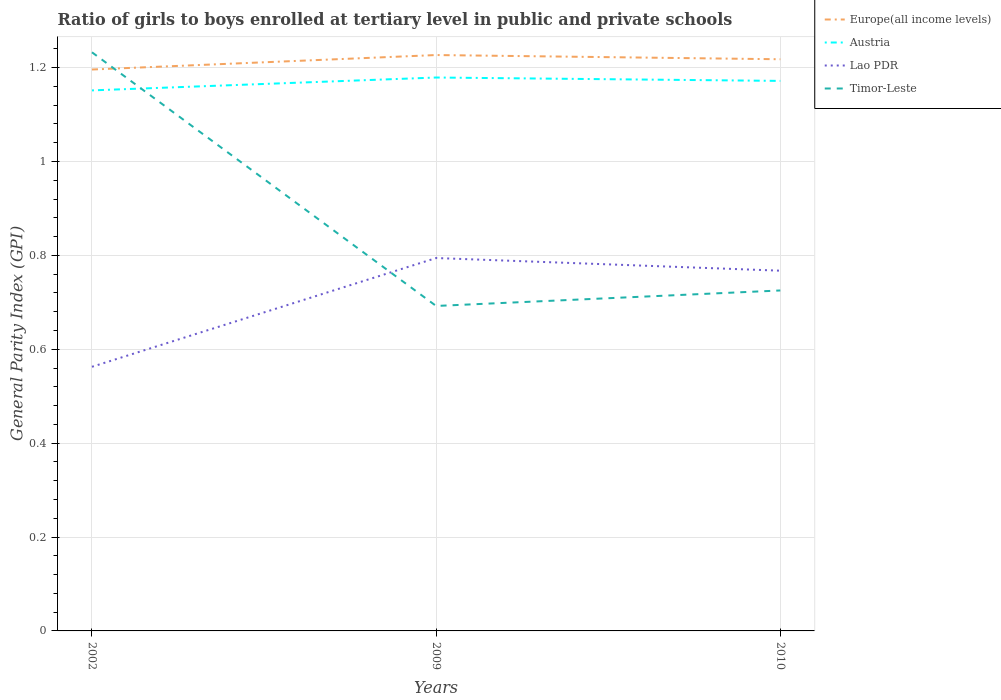How many different coloured lines are there?
Make the answer very short. 4. Across all years, what is the maximum general parity index in Lao PDR?
Offer a very short reply. 0.56. In which year was the general parity index in Austria maximum?
Your response must be concise. 2002. What is the total general parity index in Austria in the graph?
Your response must be concise. -0.02. What is the difference between the highest and the second highest general parity index in Europe(all income levels)?
Provide a succinct answer. 0.03. Is the general parity index in Timor-Leste strictly greater than the general parity index in Europe(all income levels) over the years?
Provide a succinct answer. No. Are the values on the major ticks of Y-axis written in scientific E-notation?
Your answer should be compact. No. Does the graph contain grids?
Offer a terse response. Yes. What is the title of the graph?
Your answer should be very brief. Ratio of girls to boys enrolled at tertiary level in public and private schools. Does "West Bank and Gaza" appear as one of the legend labels in the graph?
Offer a terse response. No. What is the label or title of the X-axis?
Provide a short and direct response. Years. What is the label or title of the Y-axis?
Provide a succinct answer. General Parity Index (GPI). What is the General Parity Index (GPI) of Europe(all income levels) in 2002?
Make the answer very short. 1.2. What is the General Parity Index (GPI) of Austria in 2002?
Offer a very short reply. 1.15. What is the General Parity Index (GPI) of Lao PDR in 2002?
Give a very brief answer. 0.56. What is the General Parity Index (GPI) of Timor-Leste in 2002?
Keep it short and to the point. 1.23. What is the General Parity Index (GPI) of Europe(all income levels) in 2009?
Give a very brief answer. 1.23. What is the General Parity Index (GPI) of Austria in 2009?
Give a very brief answer. 1.18. What is the General Parity Index (GPI) in Lao PDR in 2009?
Offer a terse response. 0.79. What is the General Parity Index (GPI) in Timor-Leste in 2009?
Provide a short and direct response. 0.69. What is the General Parity Index (GPI) of Europe(all income levels) in 2010?
Make the answer very short. 1.22. What is the General Parity Index (GPI) of Austria in 2010?
Your answer should be compact. 1.17. What is the General Parity Index (GPI) of Lao PDR in 2010?
Provide a short and direct response. 0.77. What is the General Parity Index (GPI) of Timor-Leste in 2010?
Keep it short and to the point. 0.73. Across all years, what is the maximum General Parity Index (GPI) of Europe(all income levels)?
Make the answer very short. 1.23. Across all years, what is the maximum General Parity Index (GPI) in Austria?
Your answer should be very brief. 1.18. Across all years, what is the maximum General Parity Index (GPI) in Lao PDR?
Your response must be concise. 0.79. Across all years, what is the maximum General Parity Index (GPI) of Timor-Leste?
Your response must be concise. 1.23. Across all years, what is the minimum General Parity Index (GPI) of Europe(all income levels)?
Your response must be concise. 1.2. Across all years, what is the minimum General Parity Index (GPI) of Austria?
Your answer should be very brief. 1.15. Across all years, what is the minimum General Parity Index (GPI) of Lao PDR?
Your response must be concise. 0.56. Across all years, what is the minimum General Parity Index (GPI) of Timor-Leste?
Give a very brief answer. 0.69. What is the total General Parity Index (GPI) of Europe(all income levels) in the graph?
Offer a very short reply. 3.64. What is the total General Parity Index (GPI) in Austria in the graph?
Keep it short and to the point. 3.5. What is the total General Parity Index (GPI) in Lao PDR in the graph?
Your answer should be very brief. 2.12. What is the total General Parity Index (GPI) in Timor-Leste in the graph?
Provide a succinct answer. 2.65. What is the difference between the General Parity Index (GPI) in Europe(all income levels) in 2002 and that in 2009?
Your response must be concise. -0.03. What is the difference between the General Parity Index (GPI) of Austria in 2002 and that in 2009?
Provide a succinct answer. -0.03. What is the difference between the General Parity Index (GPI) in Lao PDR in 2002 and that in 2009?
Give a very brief answer. -0.23. What is the difference between the General Parity Index (GPI) in Timor-Leste in 2002 and that in 2009?
Keep it short and to the point. 0.54. What is the difference between the General Parity Index (GPI) of Europe(all income levels) in 2002 and that in 2010?
Offer a very short reply. -0.02. What is the difference between the General Parity Index (GPI) in Austria in 2002 and that in 2010?
Offer a terse response. -0.02. What is the difference between the General Parity Index (GPI) in Lao PDR in 2002 and that in 2010?
Give a very brief answer. -0.2. What is the difference between the General Parity Index (GPI) of Timor-Leste in 2002 and that in 2010?
Provide a short and direct response. 0.51. What is the difference between the General Parity Index (GPI) of Europe(all income levels) in 2009 and that in 2010?
Provide a succinct answer. 0.01. What is the difference between the General Parity Index (GPI) in Austria in 2009 and that in 2010?
Ensure brevity in your answer.  0.01. What is the difference between the General Parity Index (GPI) of Lao PDR in 2009 and that in 2010?
Offer a very short reply. 0.03. What is the difference between the General Parity Index (GPI) of Timor-Leste in 2009 and that in 2010?
Offer a terse response. -0.03. What is the difference between the General Parity Index (GPI) of Europe(all income levels) in 2002 and the General Parity Index (GPI) of Austria in 2009?
Give a very brief answer. 0.02. What is the difference between the General Parity Index (GPI) in Europe(all income levels) in 2002 and the General Parity Index (GPI) in Lao PDR in 2009?
Your answer should be very brief. 0.4. What is the difference between the General Parity Index (GPI) in Europe(all income levels) in 2002 and the General Parity Index (GPI) in Timor-Leste in 2009?
Ensure brevity in your answer.  0.5. What is the difference between the General Parity Index (GPI) of Austria in 2002 and the General Parity Index (GPI) of Lao PDR in 2009?
Give a very brief answer. 0.36. What is the difference between the General Parity Index (GPI) in Austria in 2002 and the General Parity Index (GPI) in Timor-Leste in 2009?
Keep it short and to the point. 0.46. What is the difference between the General Parity Index (GPI) in Lao PDR in 2002 and the General Parity Index (GPI) in Timor-Leste in 2009?
Ensure brevity in your answer.  -0.13. What is the difference between the General Parity Index (GPI) of Europe(all income levels) in 2002 and the General Parity Index (GPI) of Austria in 2010?
Your answer should be very brief. 0.02. What is the difference between the General Parity Index (GPI) of Europe(all income levels) in 2002 and the General Parity Index (GPI) of Lao PDR in 2010?
Make the answer very short. 0.43. What is the difference between the General Parity Index (GPI) of Europe(all income levels) in 2002 and the General Parity Index (GPI) of Timor-Leste in 2010?
Keep it short and to the point. 0.47. What is the difference between the General Parity Index (GPI) of Austria in 2002 and the General Parity Index (GPI) of Lao PDR in 2010?
Your answer should be very brief. 0.38. What is the difference between the General Parity Index (GPI) of Austria in 2002 and the General Parity Index (GPI) of Timor-Leste in 2010?
Make the answer very short. 0.43. What is the difference between the General Parity Index (GPI) in Lao PDR in 2002 and the General Parity Index (GPI) in Timor-Leste in 2010?
Give a very brief answer. -0.16. What is the difference between the General Parity Index (GPI) in Europe(all income levels) in 2009 and the General Parity Index (GPI) in Austria in 2010?
Provide a succinct answer. 0.06. What is the difference between the General Parity Index (GPI) of Europe(all income levels) in 2009 and the General Parity Index (GPI) of Lao PDR in 2010?
Ensure brevity in your answer.  0.46. What is the difference between the General Parity Index (GPI) in Europe(all income levels) in 2009 and the General Parity Index (GPI) in Timor-Leste in 2010?
Offer a terse response. 0.5. What is the difference between the General Parity Index (GPI) in Austria in 2009 and the General Parity Index (GPI) in Lao PDR in 2010?
Make the answer very short. 0.41. What is the difference between the General Parity Index (GPI) of Austria in 2009 and the General Parity Index (GPI) of Timor-Leste in 2010?
Make the answer very short. 0.45. What is the difference between the General Parity Index (GPI) in Lao PDR in 2009 and the General Parity Index (GPI) in Timor-Leste in 2010?
Offer a terse response. 0.07. What is the average General Parity Index (GPI) in Europe(all income levels) per year?
Keep it short and to the point. 1.21. What is the average General Parity Index (GPI) in Austria per year?
Your response must be concise. 1.17. What is the average General Parity Index (GPI) in Lao PDR per year?
Keep it short and to the point. 0.71. What is the average General Parity Index (GPI) of Timor-Leste per year?
Offer a very short reply. 0.88. In the year 2002, what is the difference between the General Parity Index (GPI) of Europe(all income levels) and General Parity Index (GPI) of Austria?
Your answer should be compact. 0.04. In the year 2002, what is the difference between the General Parity Index (GPI) of Europe(all income levels) and General Parity Index (GPI) of Lao PDR?
Provide a short and direct response. 0.63. In the year 2002, what is the difference between the General Parity Index (GPI) in Europe(all income levels) and General Parity Index (GPI) in Timor-Leste?
Your response must be concise. -0.04. In the year 2002, what is the difference between the General Parity Index (GPI) in Austria and General Parity Index (GPI) in Lao PDR?
Your response must be concise. 0.59. In the year 2002, what is the difference between the General Parity Index (GPI) of Austria and General Parity Index (GPI) of Timor-Leste?
Offer a very short reply. -0.08. In the year 2002, what is the difference between the General Parity Index (GPI) of Lao PDR and General Parity Index (GPI) of Timor-Leste?
Your answer should be compact. -0.67. In the year 2009, what is the difference between the General Parity Index (GPI) of Europe(all income levels) and General Parity Index (GPI) of Austria?
Keep it short and to the point. 0.05. In the year 2009, what is the difference between the General Parity Index (GPI) of Europe(all income levels) and General Parity Index (GPI) of Lao PDR?
Offer a very short reply. 0.43. In the year 2009, what is the difference between the General Parity Index (GPI) of Europe(all income levels) and General Parity Index (GPI) of Timor-Leste?
Keep it short and to the point. 0.53. In the year 2009, what is the difference between the General Parity Index (GPI) in Austria and General Parity Index (GPI) in Lao PDR?
Provide a short and direct response. 0.38. In the year 2009, what is the difference between the General Parity Index (GPI) in Austria and General Parity Index (GPI) in Timor-Leste?
Your answer should be compact. 0.49. In the year 2009, what is the difference between the General Parity Index (GPI) of Lao PDR and General Parity Index (GPI) of Timor-Leste?
Make the answer very short. 0.1. In the year 2010, what is the difference between the General Parity Index (GPI) of Europe(all income levels) and General Parity Index (GPI) of Austria?
Your answer should be very brief. 0.05. In the year 2010, what is the difference between the General Parity Index (GPI) in Europe(all income levels) and General Parity Index (GPI) in Lao PDR?
Keep it short and to the point. 0.45. In the year 2010, what is the difference between the General Parity Index (GPI) of Europe(all income levels) and General Parity Index (GPI) of Timor-Leste?
Make the answer very short. 0.49. In the year 2010, what is the difference between the General Parity Index (GPI) of Austria and General Parity Index (GPI) of Lao PDR?
Offer a terse response. 0.4. In the year 2010, what is the difference between the General Parity Index (GPI) in Austria and General Parity Index (GPI) in Timor-Leste?
Your response must be concise. 0.45. In the year 2010, what is the difference between the General Parity Index (GPI) of Lao PDR and General Parity Index (GPI) of Timor-Leste?
Ensure brevity in your answer.  0.04. What is the ratio of the General Parity Index (GPI) in Europe(all income levels) in 2002 to that in 2009?
Keep it short and to the point. 0.97. What is the ratio of the General Parity Index (GPI) of Austria in 2002 to that in 2009?
Ensure brevity in your answer.  0.98. What is the ratio of the General Parity Index (GPI) in Lao PDR in 2002 to that in 2009?
Make the answer very short. 0.71. What is the ratio of the General Parity Index (GPI) in Timor-Leste in 2002 to that in 2009?
Provide a succinct answer. 1.78. What is the ratio of the General Parity Index (GPI) in Europe(all income levels) in 2002 to that in 2010?
Your response must be concise. 0.98. What is the ratio of the General Parity Index (GPI) in Austria in 2002 to that in 2010?
Offer a very short reply. 0.98. What is the ratio of the General Parity Index (GPI) of Lao PDR in 2002 to that in 2010?
Keep it short and to the point. 0.73. What is the ratio of the General Parity Index (GPI) of Timor-Leste in 2002 to that in 2010?
Keep it short and to the point. 1.7. What is the ratio of the General Parity Index (GPI) in Europe(all income levels) in 2009 to that in 2010?
Ensure brevity in your answer.  1.01. What is the ratio of the General Parity Index (GPI) of Lao PDR in 2009 to that in 2010?
Ensure brevity in your answer.  1.04. What is the ratio of the General Parity Index (GPI) of Timor-Leste in 2009 to that in 2010?
Your answer should be compact. 0.95. What is the difference between the highest and the second highest General Parity Index (GPI) in Europe(all income levels)?
Your response must be concise. 0.01. What is the difference between the highest and the second highest General Parity Index (GPI) in Austria?
Provide a short and direct response. 0.01. What is the difference between the highest and the second highest General Parity Index (GPI) in Lao PDR?
Give a very brief answer. 0.03. What is the difference between the highest and the second highest General Parity Index (GPI) in Timor-Leste?
Your answer should be compact. 0.51. What is the difference between the highest and the lowest General Parity Index (GPI) in Europe(all income levels)?
Give a very brief answer. 0.03. What is the difference between the highest and the lowest General Parity Index (GPI) in Austria?
Offer a very short reply. 0.03. What is the difference between the highest and the lowest General Parity Index (GPI) of Lao PDR?
Ensure brevity in your answer.  0.23. What is the difference between the highest and the lowest General Parity Index (GPI) of Timor-Leste?
Provide a short and direct response. 0.54. 